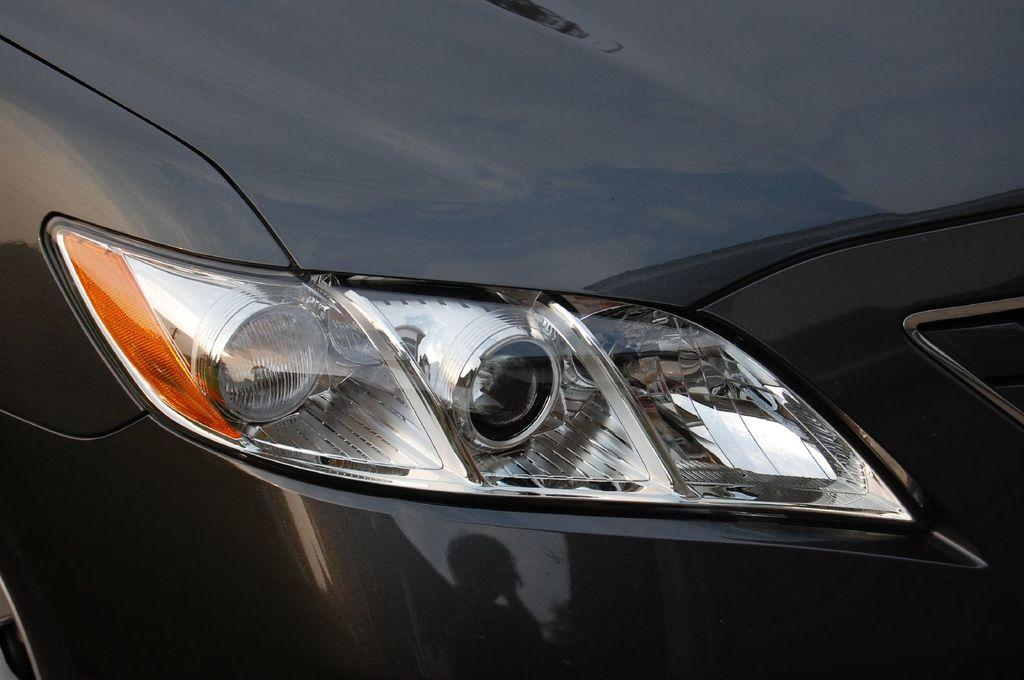What is the color of the car in the image? The car in the image is black. What part of the car is visible and indicates its intended direction? There is an indicator visible on the car. What are the lights on the front of the car called? There are headlights visible on the car. Where is the mine located in the image? There is no mine present in the image. How many turkeys can be seen walking around the car in the image? There are no turkeys present in the image. 